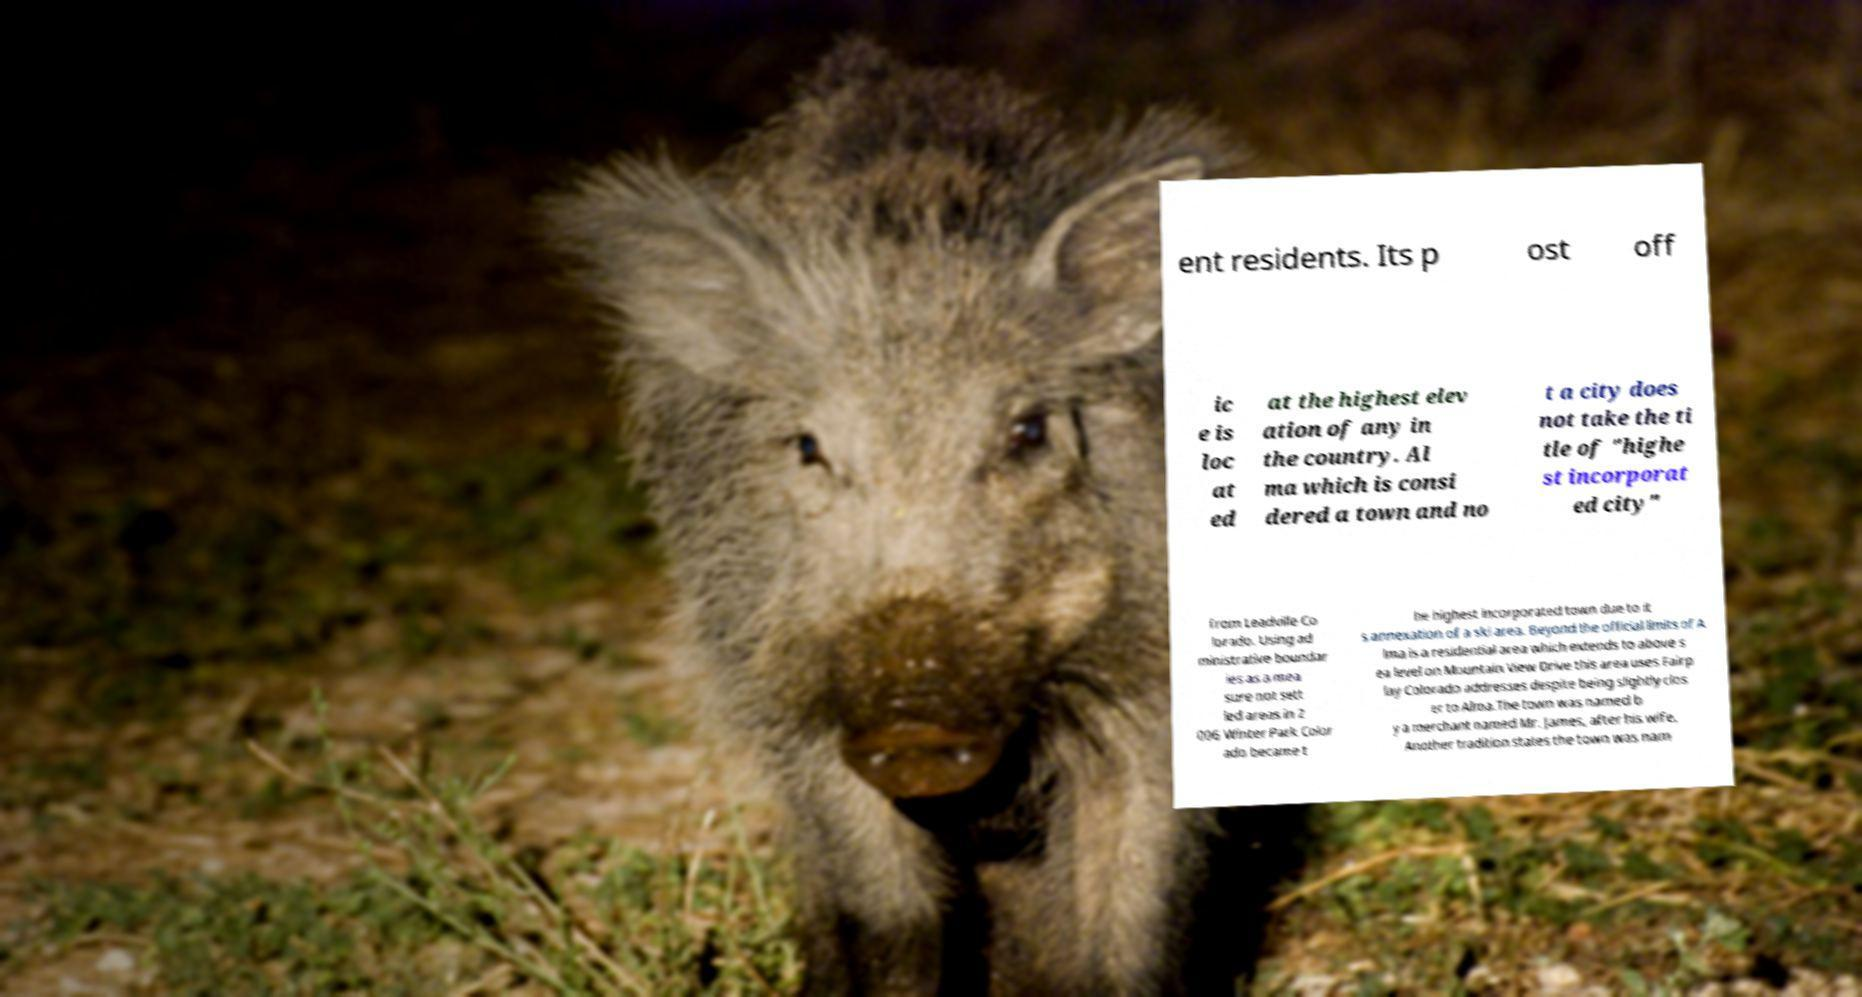What messages or text are displayed in this image? I need them in a readable, typed format. ent residents. Its p ost off ic e is loc at ed at the highest elev ation of any in the country. Al ma which is consi dered a town and no t a city does not take the ti tle of "highe st incorporat ed city" from Leadville Co lorado. Using ad ministrative boundar ies as a mea sure not sett led areas in 2 006 Winter Park Color ado became t he highest incorporated town due to it s annexation of a ski area. Beyond the official limits of A lma is a residential area which extends to above s ea level on Mountain View Drive this area uses Fairp lay Colorado addresses despite being slightly clos er to Alma.The town was named b y a merchant named Mr. James, after his wife. Another tradition states the town was nam 